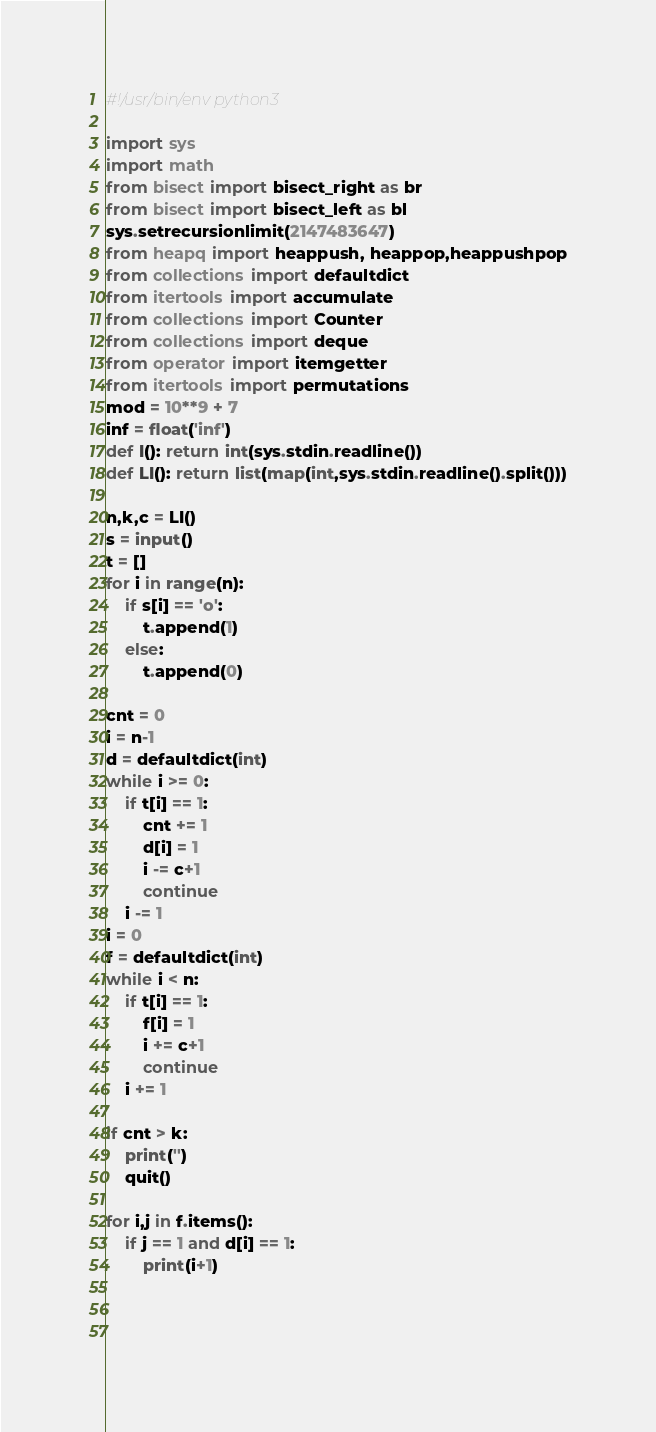Convert code to text. <code><loc_0><loc_0><loc_500><loc_500><_Python_>#!/usr/bin/env python3

import sys
import math
from bisect import bisect_right as br
from bisect import bisect_left as bl
sys.setrecursionlimit(2147483647)
from heapq import heappush, heappop,heappushpop
from collections import defaultdict
from itertools import accumulate
from collections import Counter
from collections import deque
from operator import itemgetter
from itertools import permutations
mod = 10**9 + 7
inf = float('inf')
def I(): return int(sys.stdin.readline())
def LI(): return list(map(int,sys.stdin.readline().split()))

n,k,c = LI()
s = input()
t = []
for i in range(n):
    if s[i] == 'o':
        t.append(1)
    else:
        t.append(0)

cnt = 0
i = n-1
d = defaultdict(int)
while i >= 0:
    if t[i] == 1:
        cnt += 1
        d[i] = 1
        i -= c+1
        continue
    i -= 1
i = 0
f = defaultdict(int)
while i < n:
    if t[i] == 1:
        f[i] = 1
        i += c+1
        continue
    i += 1
        
if cnt > k:
    print('')
    quit()

for i,j in f.items():
    if j == 1 and d[i] == 1:
        print(i+1)


     

</code> 